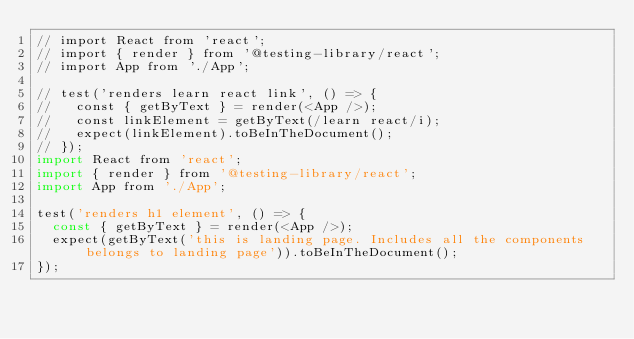Convert code to text. <code><loc_0><loc_0><loc_500><loc_500><_JavaScript_>// import React from 'react';
// import { render } from '@testing-library/react';
// import App from './App';

// test('renders learn react link', () => {
//   const { getByText } = render(<App />);
//   const linkElement = getByText(/learn react/i);
//   expect(linkElement).toBeInTheDocument();
// });
import React from 'react';
import { render } from '@testing-library/react';
import App from './App';

test('renders h1 element', () => {
  const { getByText } = render(<App />);
  expect(getByText('this is landing page. Includes all the components belongs to landing page')).toBeInTheDocument();
});
</code> 